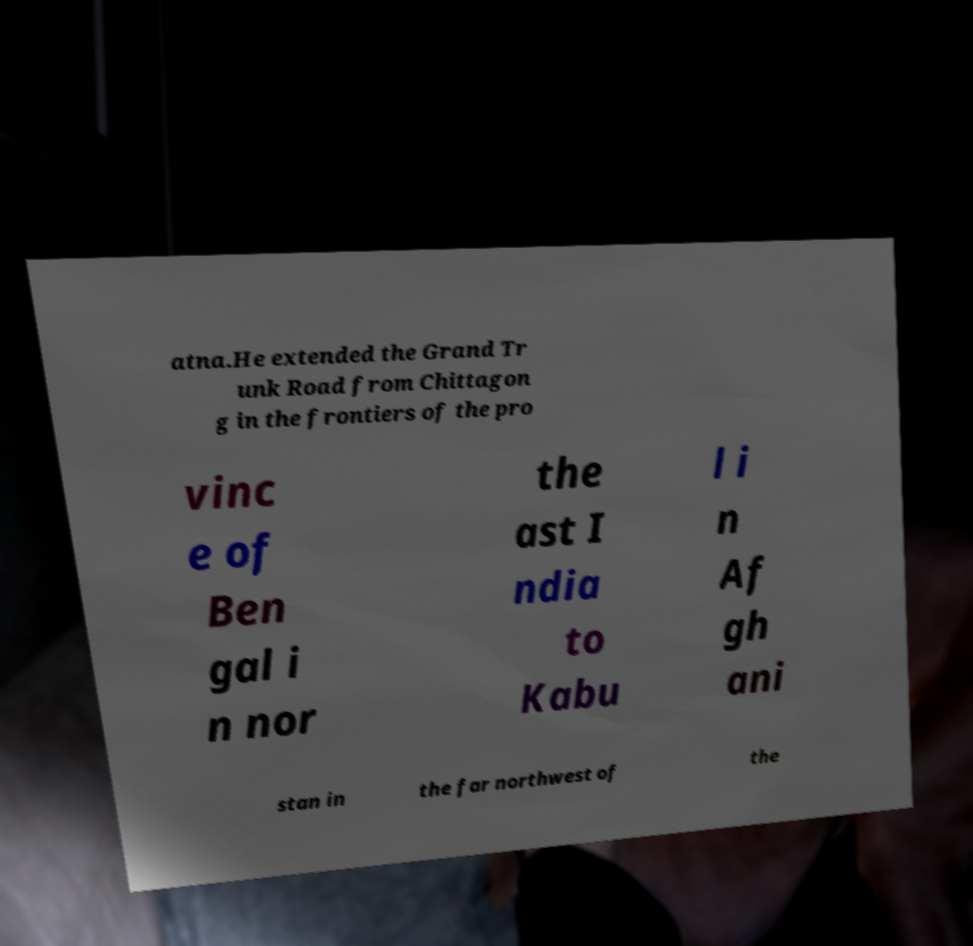Please read and relay the text visible in this image. What does it say? atna.He extended the Grand Tr unk Road from Chittagon g in the frontiers of the pro vinc e of Ben gal i n nor the ast I ndia to Kabu l i n Af gh ani stan in the far northwest of the 